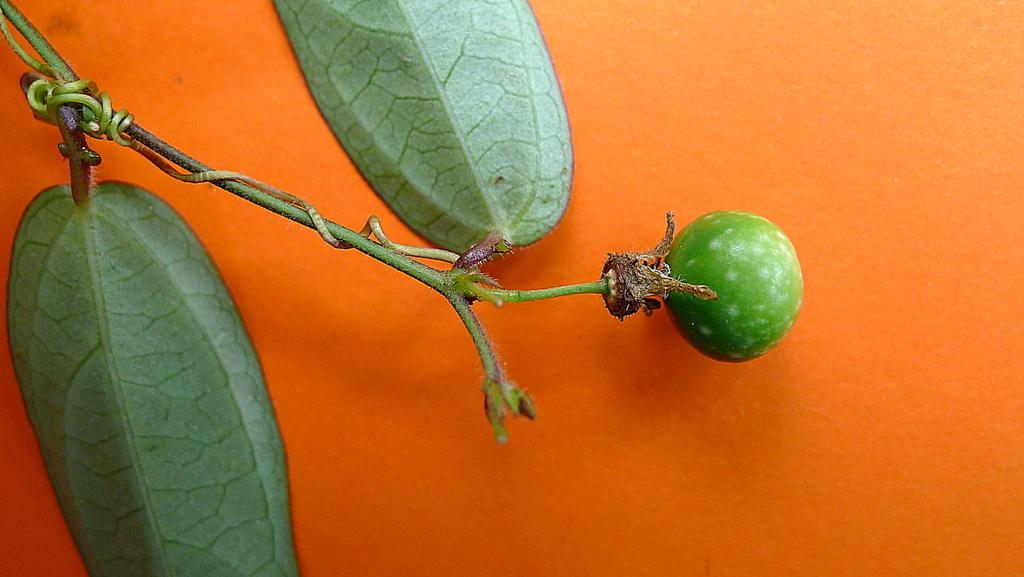What is the main object in the image? There is a stem in the image. What is attached to the stem? There is a vegetable attached to the stem in the image. Where is the vegetable located in relation to the image? The vegetable is visible on the right side of the image. What can be seen in the background of the image? The background of the image is in orange color. Can you see a dog playing with a lamp in the stream in the image? There is no dog, lamp, or stream present in the image. 